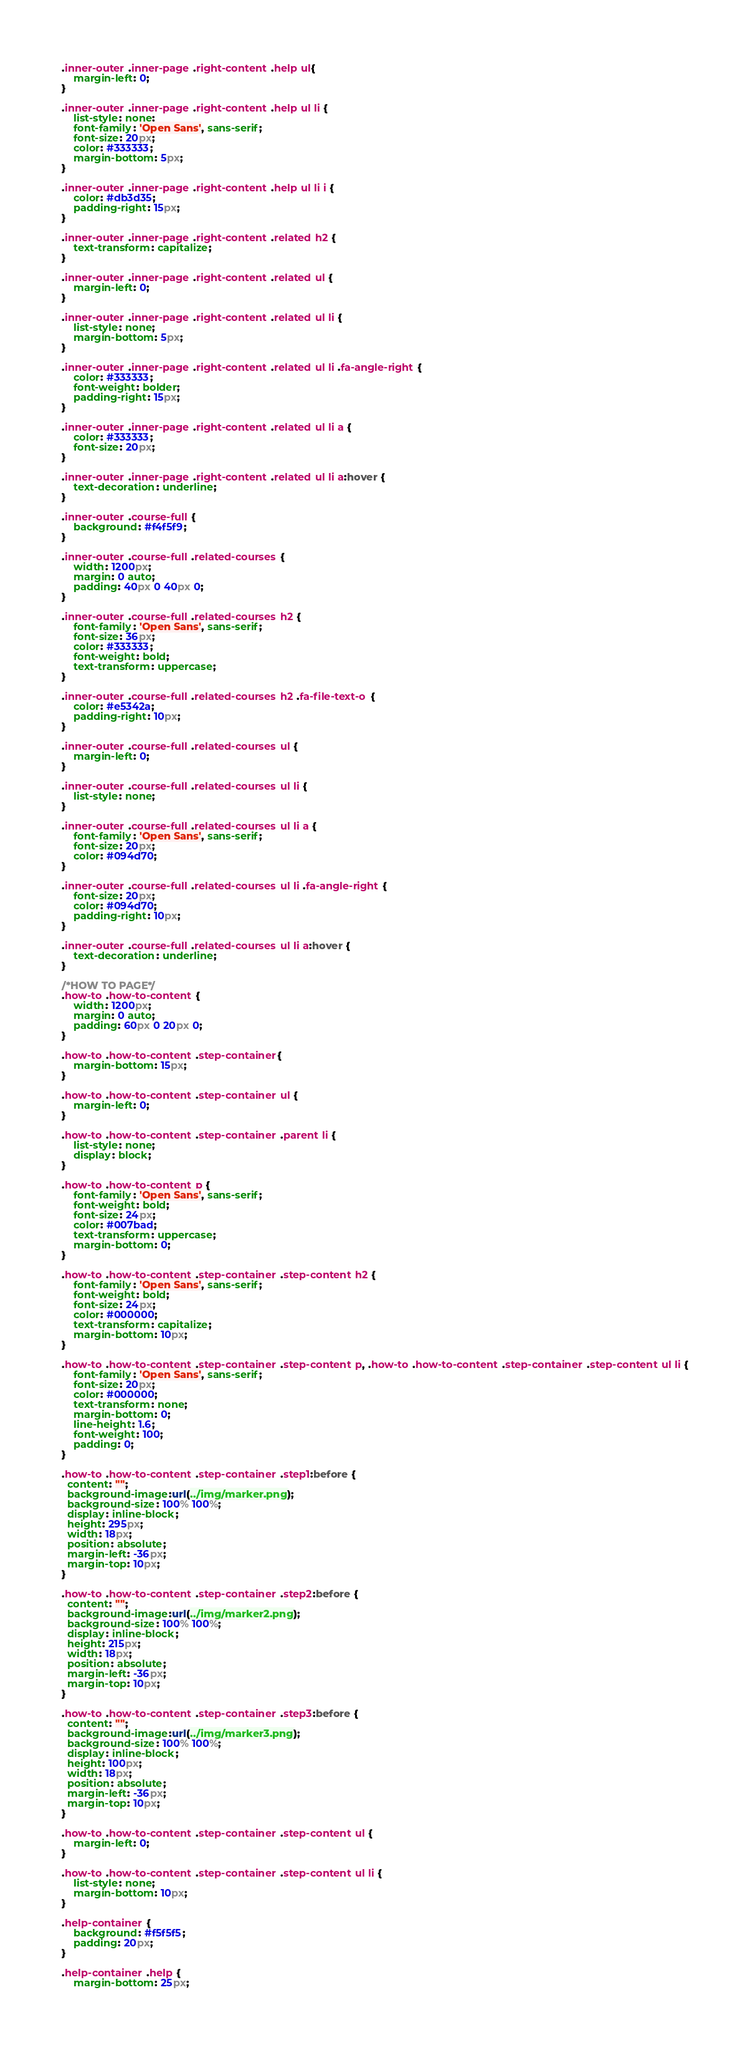Convert code to text. <code><loc_0><loc_0><loc_500><loc_500><_CSS_>
.inner-outer .inner-page .right-content .help ul{
    margin-left: 0;
}

.inner-outer .inner-page .right-content .help ul li {
    list-style: none;
    font-family: 'Open Sans', sans-serif;
    font-size: 20px;
    color: #333333;
    margin-bottom: 5px;
}

.inner-outer .inner-page .right-content .help ul li i {
    color: #db3d35;
    padding-right: 15px;
}

.inner-outer .inner-page .right-content .related h2 {
    text-transform: capitalize;
}

.inner-outer .inner-page .right-content .related ul {
    margin-left: 0;
}

.inner-outer .inner-page .right-content .related ul li {
    list-style: none;
    margin-bottom: 5px;
}

.inner-outer .inner-page .right-content .related ul li .fa-angle-right {
    color: #333333;
    font-weight: bolder;
    padding-right: 15px;
}

.inner-outer .inner-page .right-content .related ul li a {
    color: #333333;
    font-size: 20px;
}

.inner-outer .inner-page .right-content .related ul li a:hover {
    text-decoration: underline;
}

.inner-outer .course-full {
    background: #f4f5f9;
}

.inner-outer .course-full .related-courses {
    width: 1200px;
    margin: 0 auto;
    padding: 40px 0 40px 0;
}

.inner-outer .course-full .related-courses h2 {
    font-family: 'Open Sans', sans-serif;
    font-size: 36px;
    color: #333333;
    font-weight: bold;
    text-transform: uppercase;
}

.inner-outer .course-full .related-courses h2 .fa-file-text-o {
    color: #e5342a;
    padding-right: 10px;
}

.inner-outer .course-full .related-courses ul {
    margin-left: 0;
}

.inner-outer .course-full .related-courses ul li {
    list-style: none;
}

.inner-outer .course-full .related-courses ul li a {
    font-family: 'Open Sans', sans-serif;
    font-size: 20px;
    color: #094d70;
}

.inner-outer .course-full .related-courses ul li .fa-angle-right {
    font-size: 20px;
    color: #094d70;
    padding-right: 10px;
}

.inner-outer .course-full .related-courses ul li a:hover {
    text-decoration: underline;
}

/*HOW TO PAGE*/
.how-to .how-to-content {
    width: 1200px;
    margin: 0 auto;
    padding: 60px 0 20px 0;
}

.how-to .how-to-content .step-container{
    margin-bottom: 15px;
}

.how-to .how-to-content .step-container ul {
    margin-left: 0;
}

.how-to .how-to-content .step-container .parent li {
    list-style: none;
    display: block;
}

.how-to .how-to-content p {
    font-family: 'Open Sans', sans-serif;
    font-weight: bold;
    font-size: 24px;
    color: #007bad;
    text-transform: uppercase;
    margin-bottom: 0;
}

.how-to .how-to-content .step-container .step-content h2 {
    font-family: 'Open Sans', sans-serif;
    font-weight: bold;
    font-size: 24px;
    color: #000000;
    text-transform: capitalize;
    margin-bottom: 10px;
}

.how-to .how-to-content .step-container .step-content p, .how-to .how-to-content .step-container .step-content ul li {
    font-family: 'Open Sans', sans-serif;
    font-size: 20px;
    color: #000000;
    text-transform: none;
    margin-bottom: 0;
    line-height: 1.6;
    font-weight: 100;
    padding: 0;
}

.how-to .how-to-content .step-container .step1:before {
  content: "";
  background-image:url(../img/marker.png);
  background-size: 100% 100%;
  display: inline-block;
  height: 295px;
  width: 18px;
  position: absolute;
  margin-left: -36px;
  margin-top: 10px;
}

.how-to .how-to-content .step-container .step2:before {
  content: "";
  background-image:url(../img/marker2.png);
  background-size: 100% 100%;
  display: inline-block;
  height: 215px;
  width: 18px;
  position: absolute;
  margin-left: -36px;
  margin-top: 10px;
}

.how-to .how-to-content .step-container .step3:before {
  content: "";
  background-image:url(../img/marker3.png);
  background-size: 100% 100%;
  display: inline-block;
  height: 100px;
  width: 18px;
  position: absolute;
  margin-left: -36px;
  margin-top: 10px;
}

.how-to .how-to-content .step-container .step-content ul {
    margin-left: 0;
}

.how-to .how-to-content .step-container .step-content ul li {
    list-style: none;   
    margin-bottom: 10px;
}

.help-container {
    background: #f5f5f5;
    padding: 20px;
}

.help-container .help {
    margin-bottom: 25px;</code> 